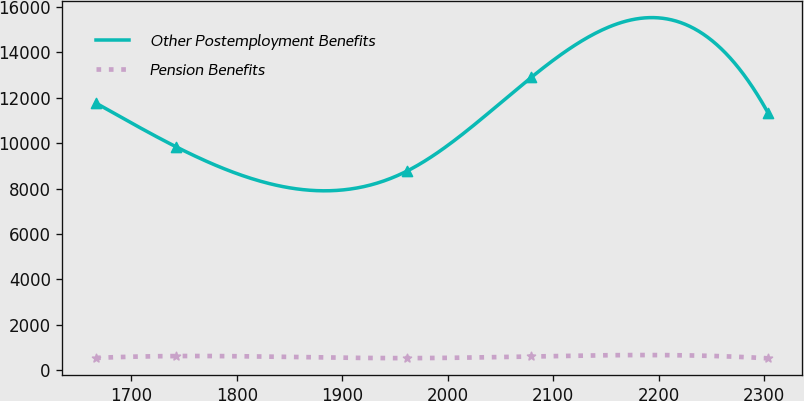Convert chart. <chart><loc_0><loc_0><loc_500><loc_500><line_chart><ecel><fcel>Other Postemployment Benefits<fcel>Pension Benefits<nl><fcel>1666.61<fcel>11764<fcel>546.99<nl><fcel>1742.51<fcel>9841.4<fcel>628.25<nl><fcel>1961.04<fcel>8768.24<fcel>536.83<nl><fcel>2079.09<fcel>12900.9<fcel>611.28<nl><fcel>2303.85<fcel>11310.6<fcel>526.67<nl></chart> 